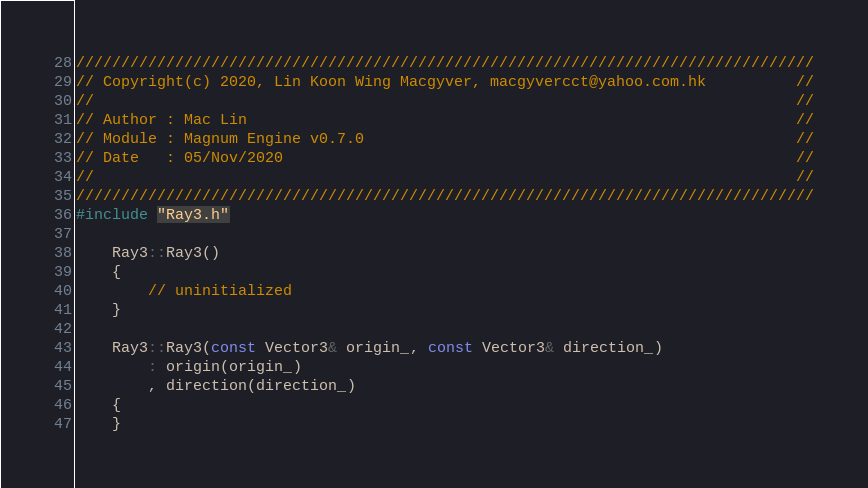<code> <loc_0><loc_0><loc_500><loc_500><_C++_>//////////////////////////////////////////////////////////////////////////////////
// Copyright(c) 2020, Lin Koon Wing Macgyver, macgyvercct@yahoo.com.hk          //
//																				//
// Author : Mac Lin																//
// Module : Magnum Engine v0.7.0												//
// Date   : 05/Nov/2020															//
//																				//
//////////////////////////////////////////////////////////////////////////////////
#include "Ray3.h"

    Ray3::Ray3()
    {
        // uninitialized
    }

    Ray3::Ray3(const Vector3& origin_, const Vector3& direction_)
        : origin(origin_)
        , direction(direction_)
    {
    }</code> 